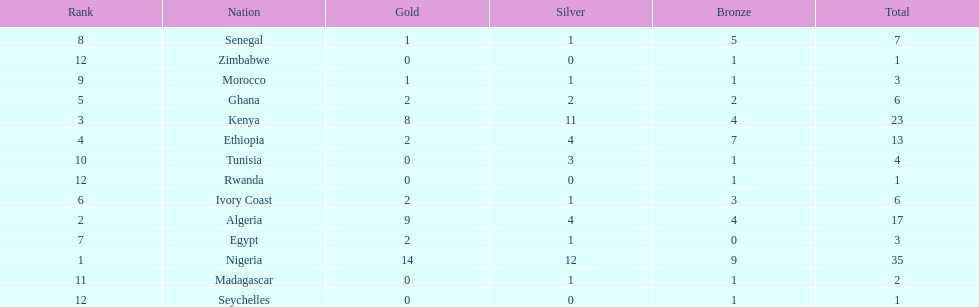The country that won the most medals was? Nigeria. 